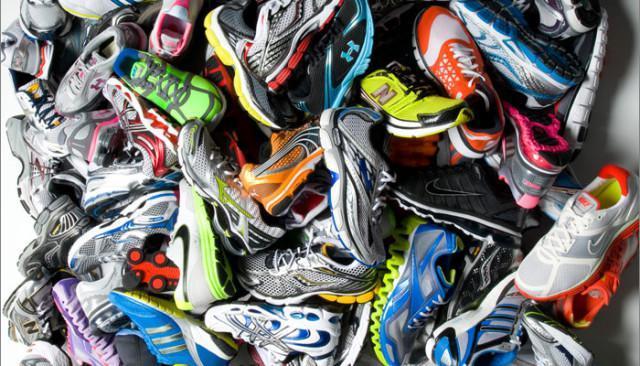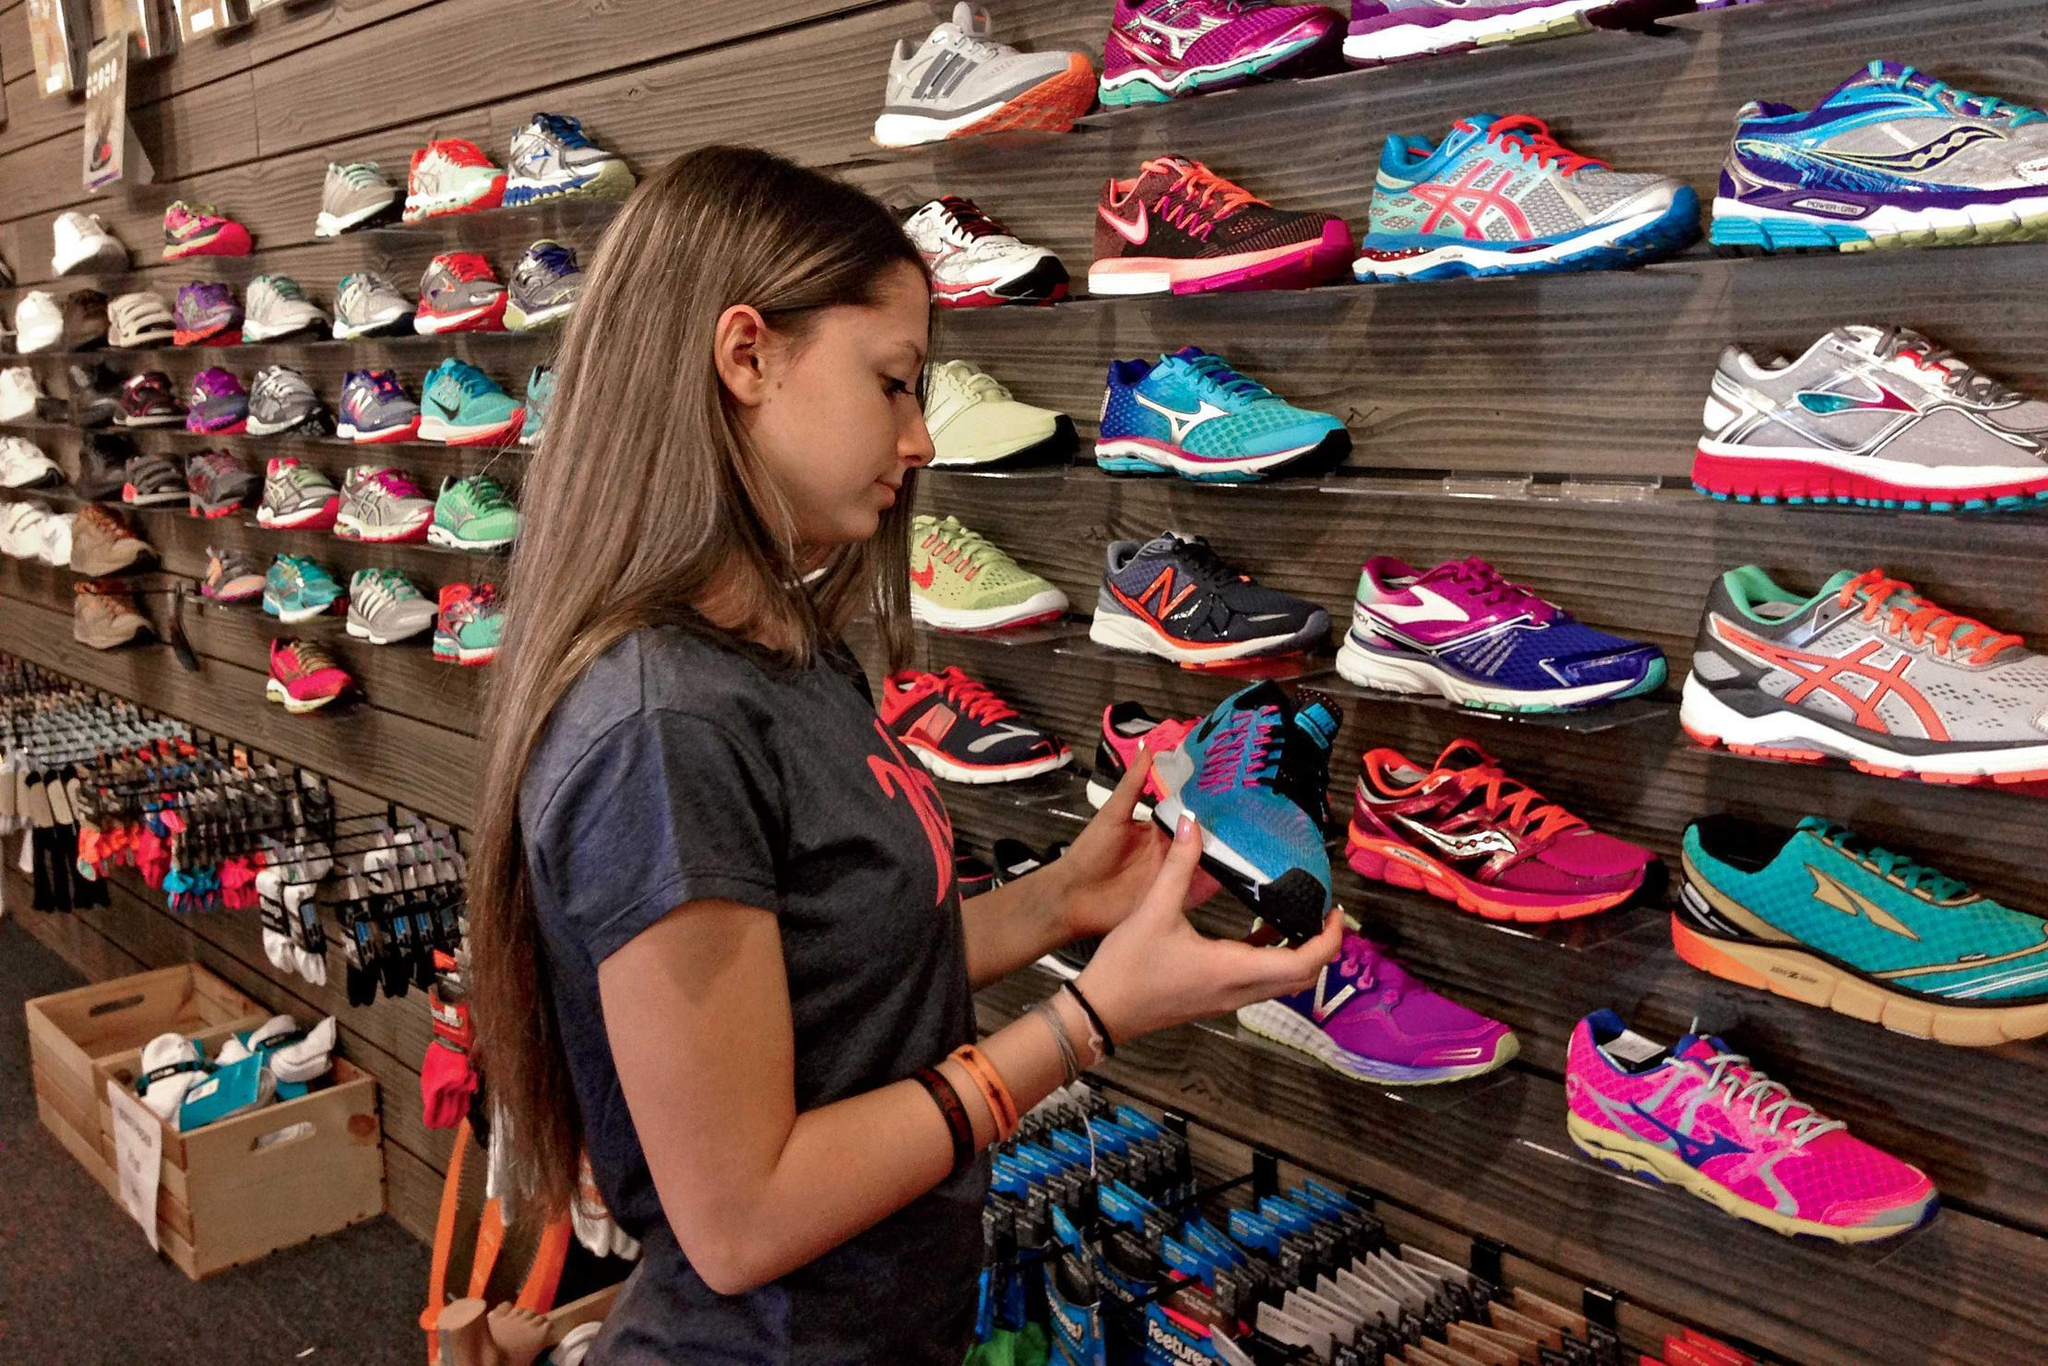The first image is the image on the left, the second image is the image on the right. Analyze the images presented: Is the assertion "One image shows only one pair of black shoes with white and yellow trim." valid? Answer yes or no. No. 